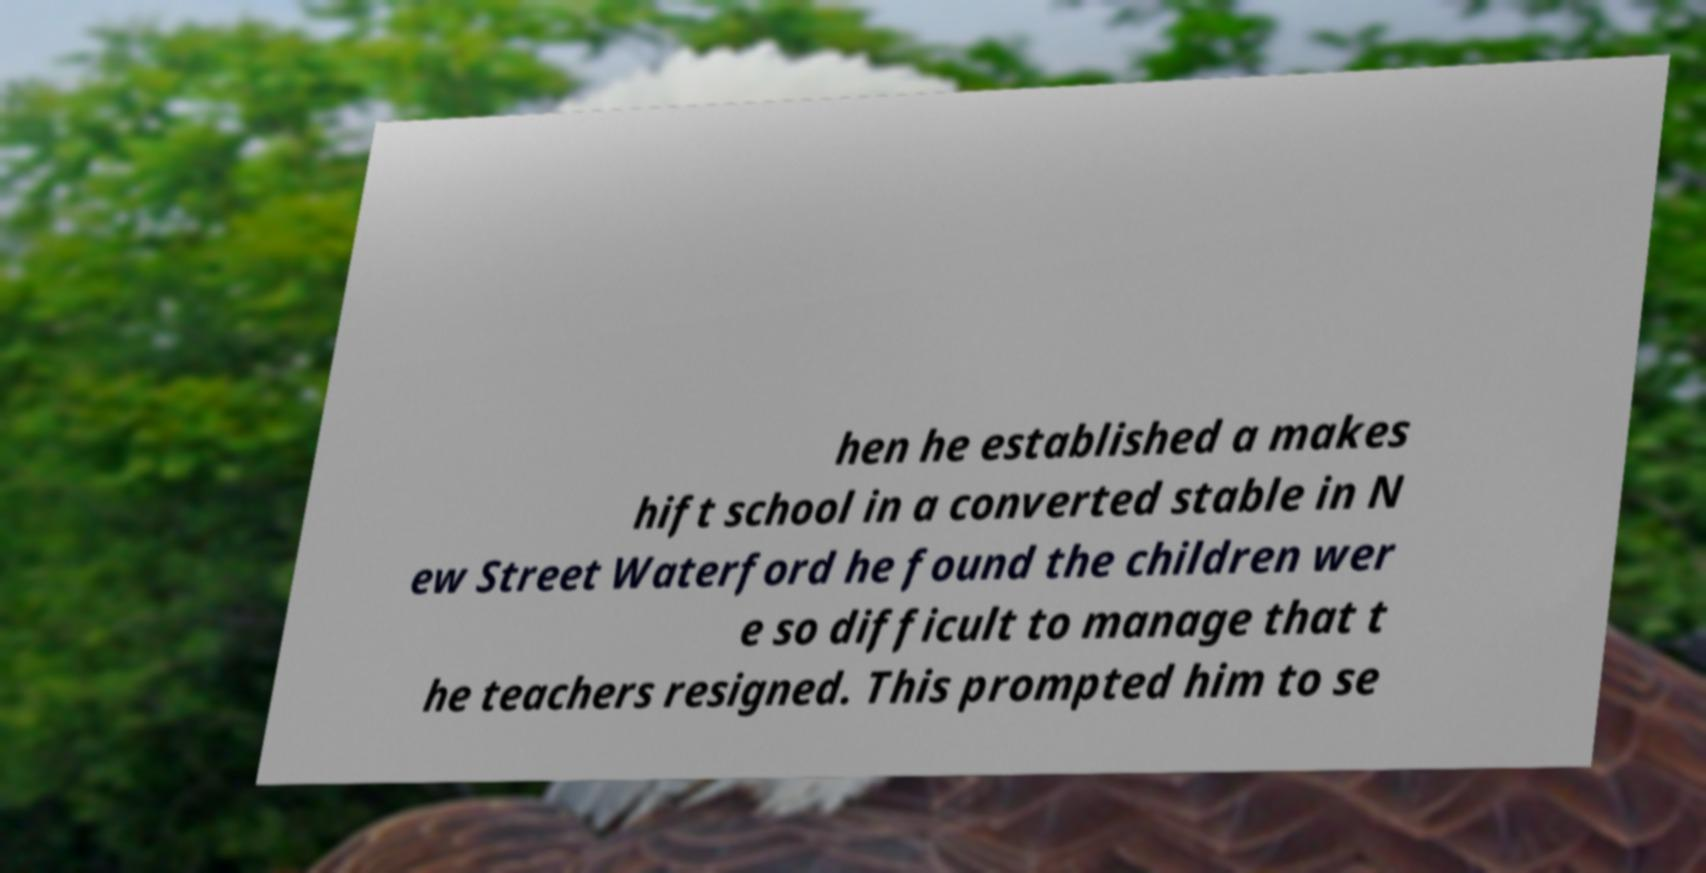Could you extract and type out the text from this image? hen he established a makes hift school in a converted stable in N ew Street Waterford he found the children wer e so difficult to manage that t he teachers resigned. This prompted him to se 